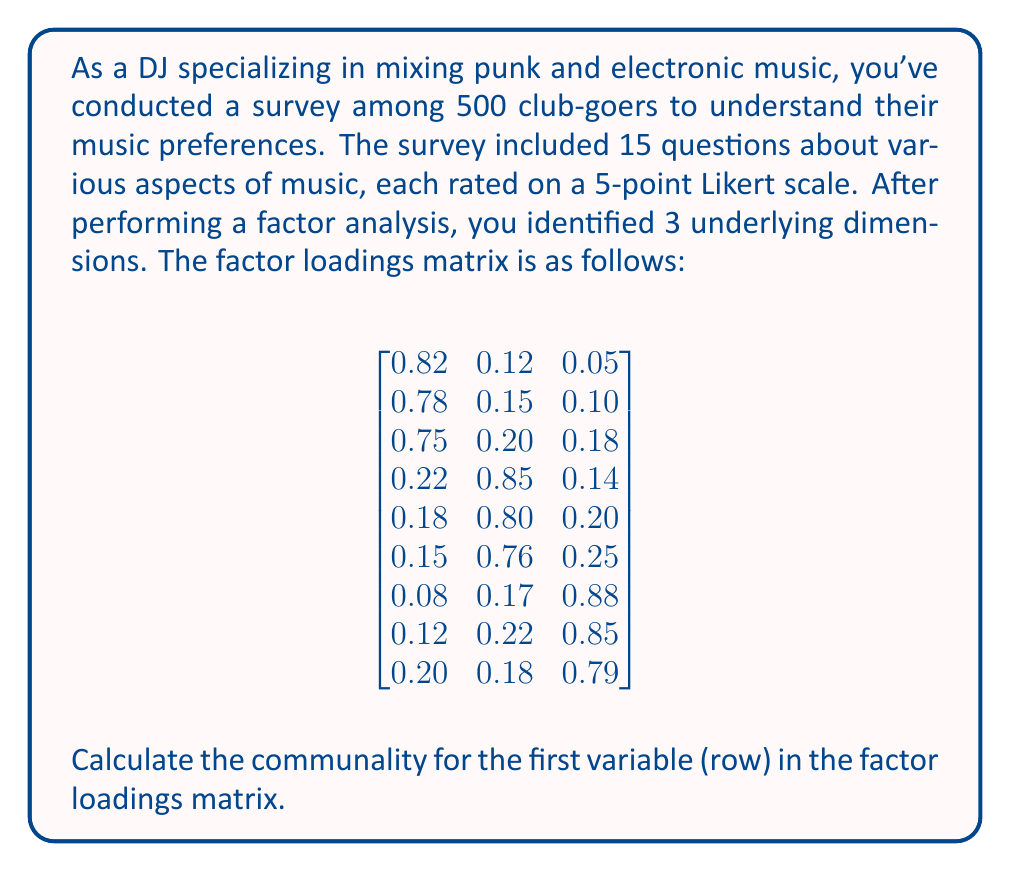Could you help me with this problem? To solve this problem, we need to understand what communality is and how to calculate it using the factor loadings matrix.

1. Communality represents the proportion of a variable's variance that can be explained by the common factors. It is calculated as the sum of squared factor loadings for that variable across all factors.

2. For the first variable (row) in the factor loadings matrix, we have:
   - Loading on Factor 1: 0.82
   - Loading on Factor 2: 0.12
   - Loading on Factor 3: 0.05

3. To calculate the communality, we need to square each of these loadings and sum them up:

   $h^2 = (0.82)^2 + (0.12)^2 + (0.05)^2$

4. Let's calculate each term:
   - $(0.82)^2 = 0.6724$
   - $(0.12)^2 = 0.0144$
   - $(0.05)^2 = 0.0025$

5. Now, we sum these squared loadings:

   $h^2 = 0.6724 + 0.0144 + 0.0025 = 0.6893$

6. The communality for the first variable is 0.6893, which means that approximately 68.93% of this variable's variance is explained by the three common factors.
Answer: $h^2 = 0.6893$ 